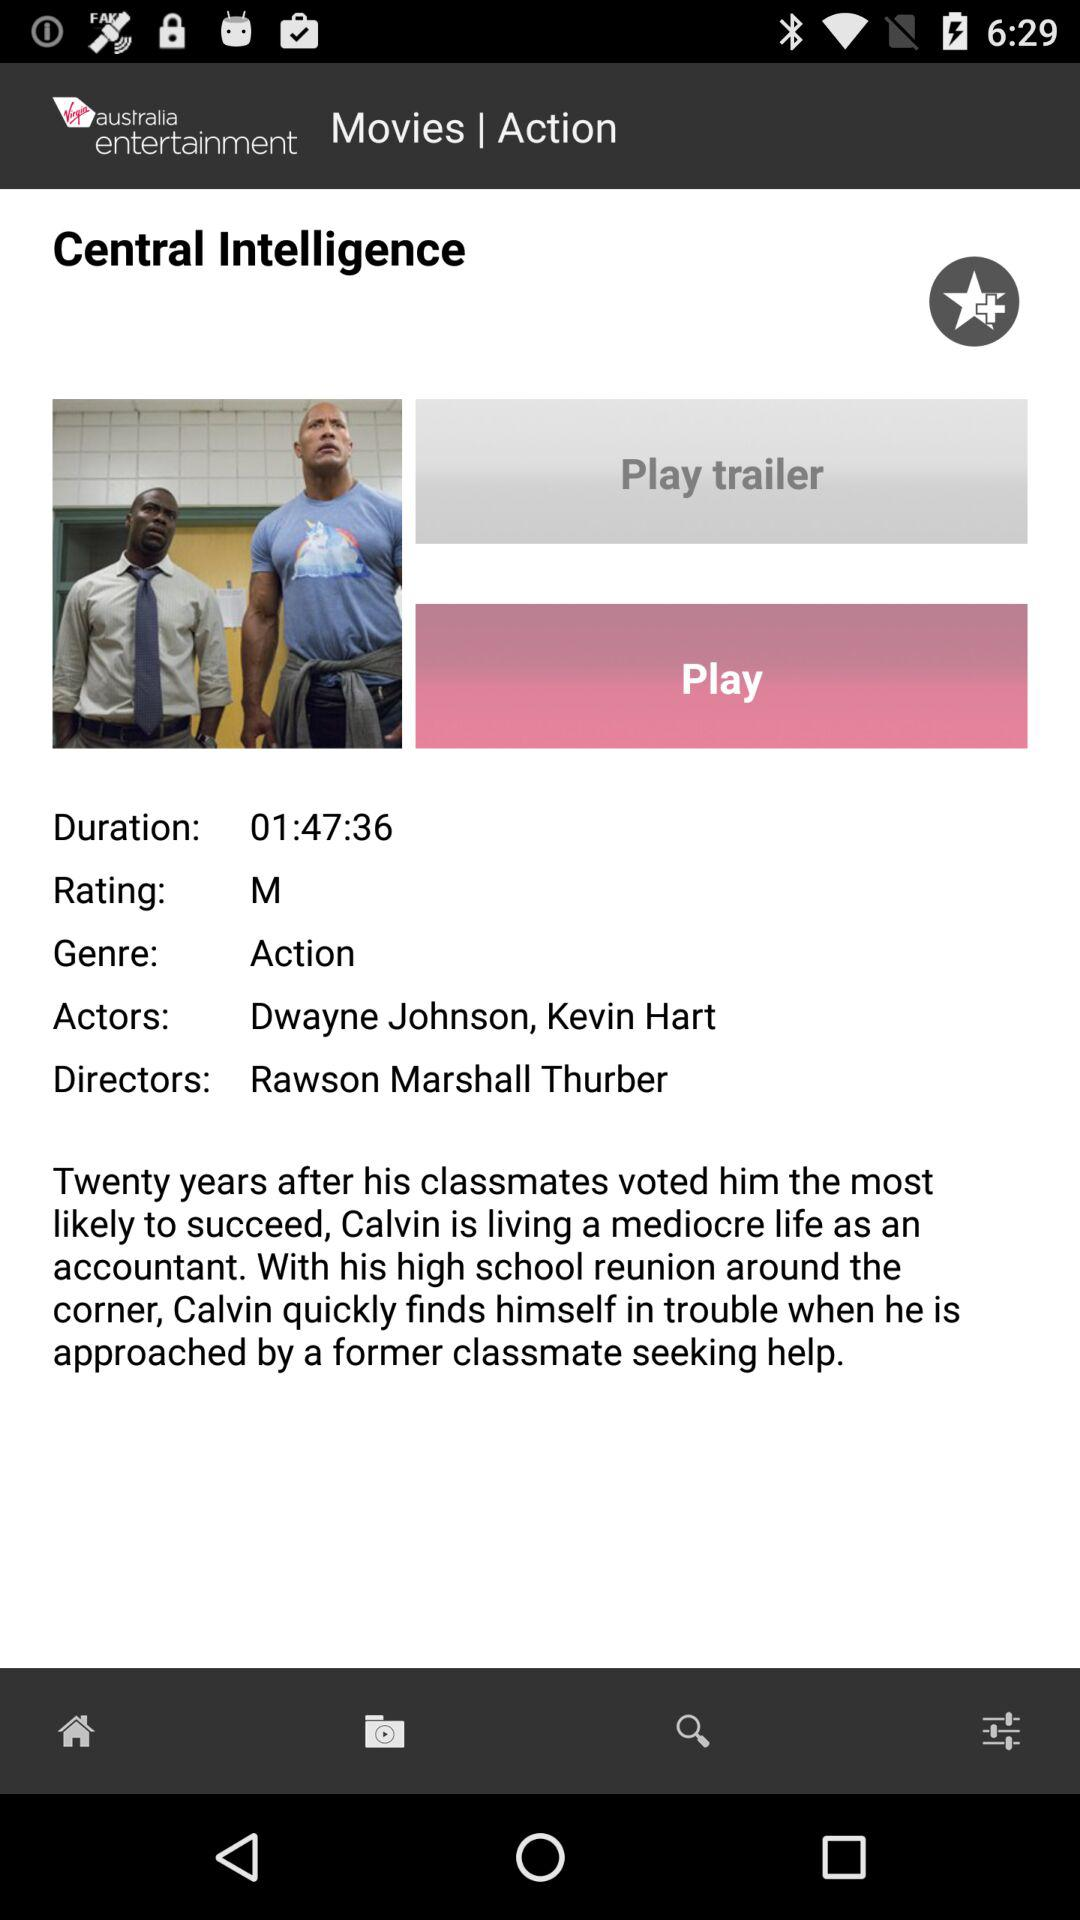What is the genre of the movie? The genre of the movie is action. 